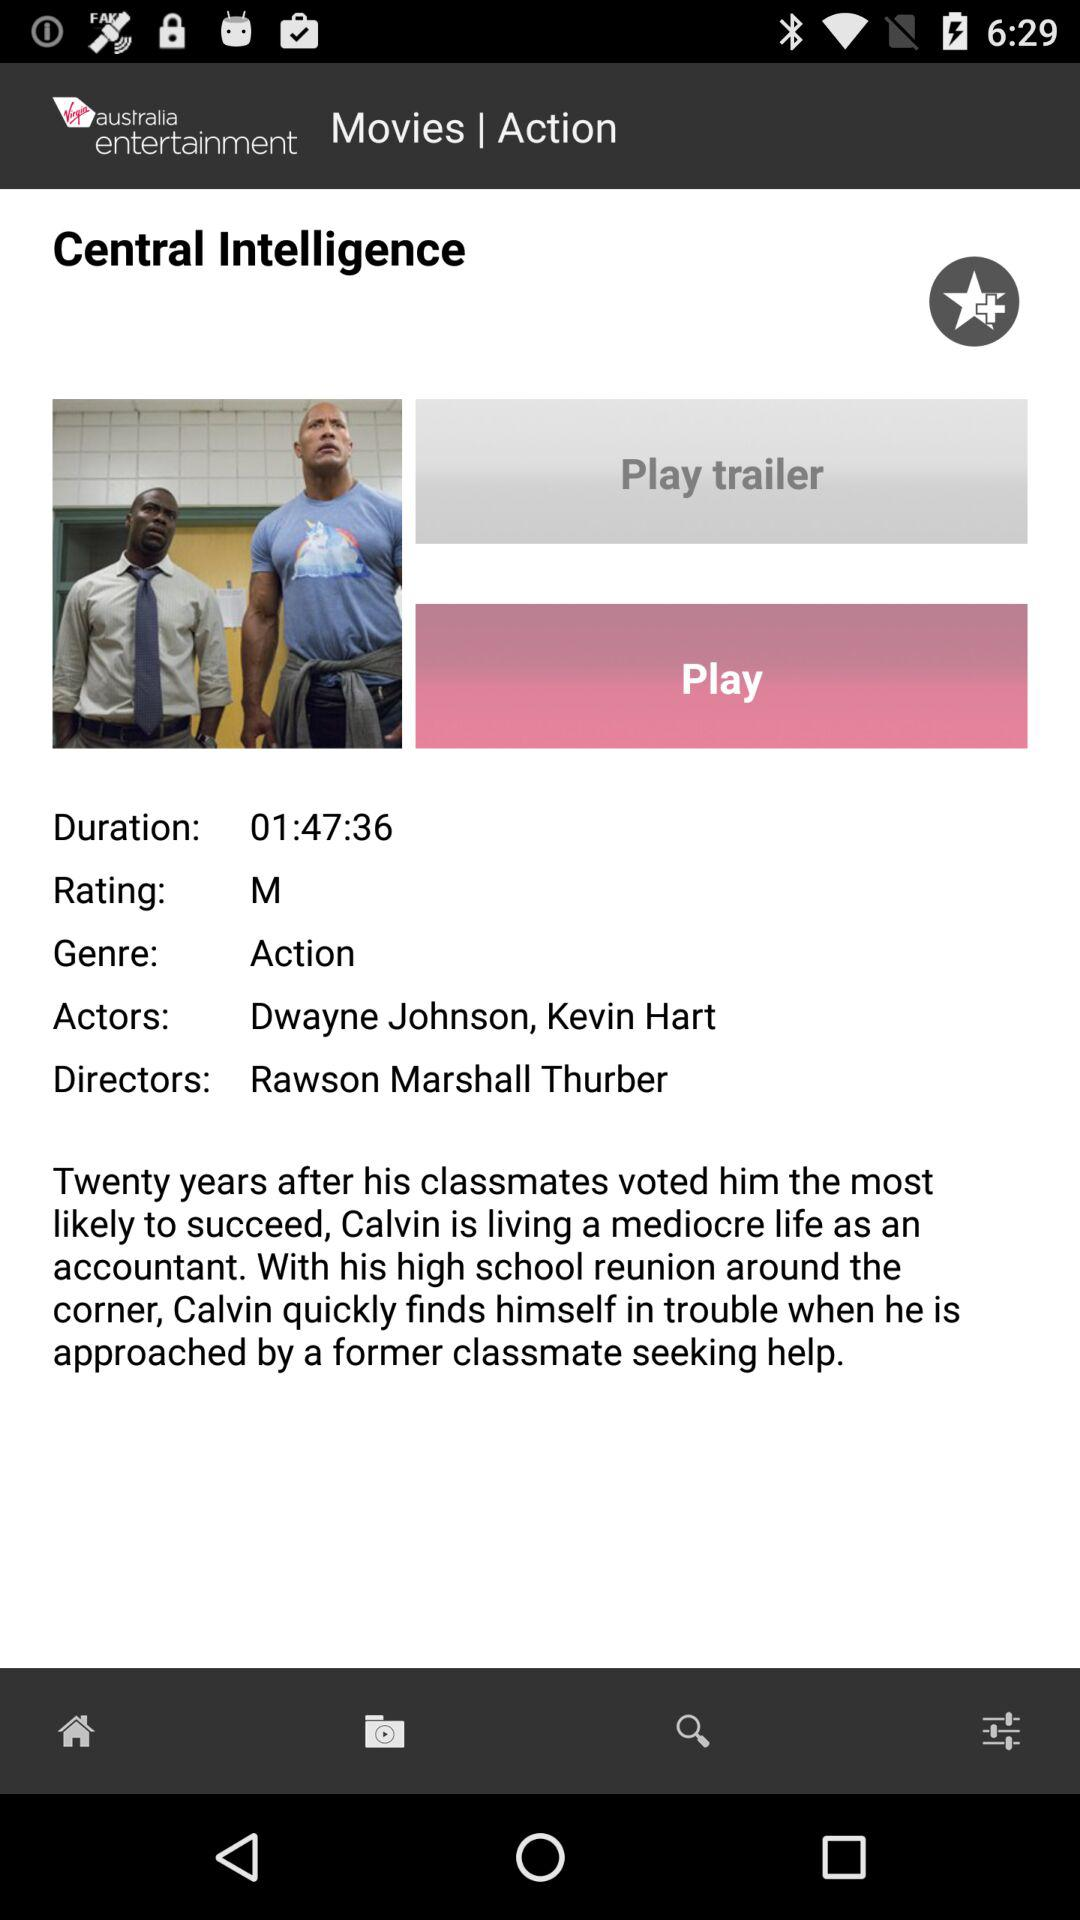What is the genre of the movie? The genre of the movie is action. 